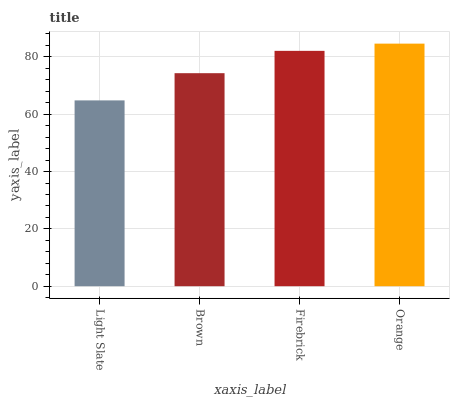Is Light Slate the minimum?
Answer yes or no. Yes. Is Orange the maximum?
Answer yes or no. Yes. Is Brown the minimum?
Answer yes or no. No. Is Brown the maximum?
Answer yes or no. No. Is Brown greater than Light Slate?
Answer yes or no. Yes. Is Light Slate less than Brown?
Answer yes or no. Yes. Is Light Slate greater than Brown?
Answer yes or no. No. Is Brown less than Light Slate?
Answer yes or no. No. Is Firebrick the high median?
Answer yes or no. Yes. Is Brown the low median?
Answer yes or no. Yes. Is Brown the high median?
Answer yes or no. No. Is Firebrick the low median?
Answer yes or no. No. 